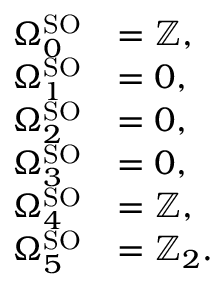Convert formula to latex. <formula><loc_0><loc_0><loc_500><loc_500>{ \begin{array} { r l } { \Omega _ { 0 } ^ { S O } } & { = \mathbb { Z } , } \\ { \Omega _ { 1 } ^ { S O } } & { = 0 , } \\ { \Omega _ { 2 } ^ { S O } } & { = 0 , } \\ { \Omega _ { 3 } ^ { S O } } & { = 0 , } \\ { \Omega _ { 4 } ^ { S O } } & { = \mathbb { Z } , } \\ { \Omega _ { 5 } ^ { S O } } & { = \mathbb { Z } _ { 2 } . } \end{array} }</formula> 